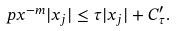<formula> <loc_0><loc_0><loc_500><loc_500>\ p x ^ { - m } | x _ { j } | \leq \tau | x _ { j } | + C ^ { \prime } _ { \tau } .</formula> 